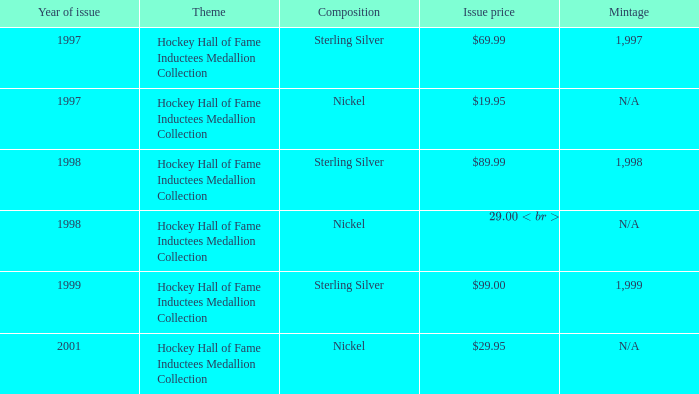How many years was the issue price $19.95? 1.0. 